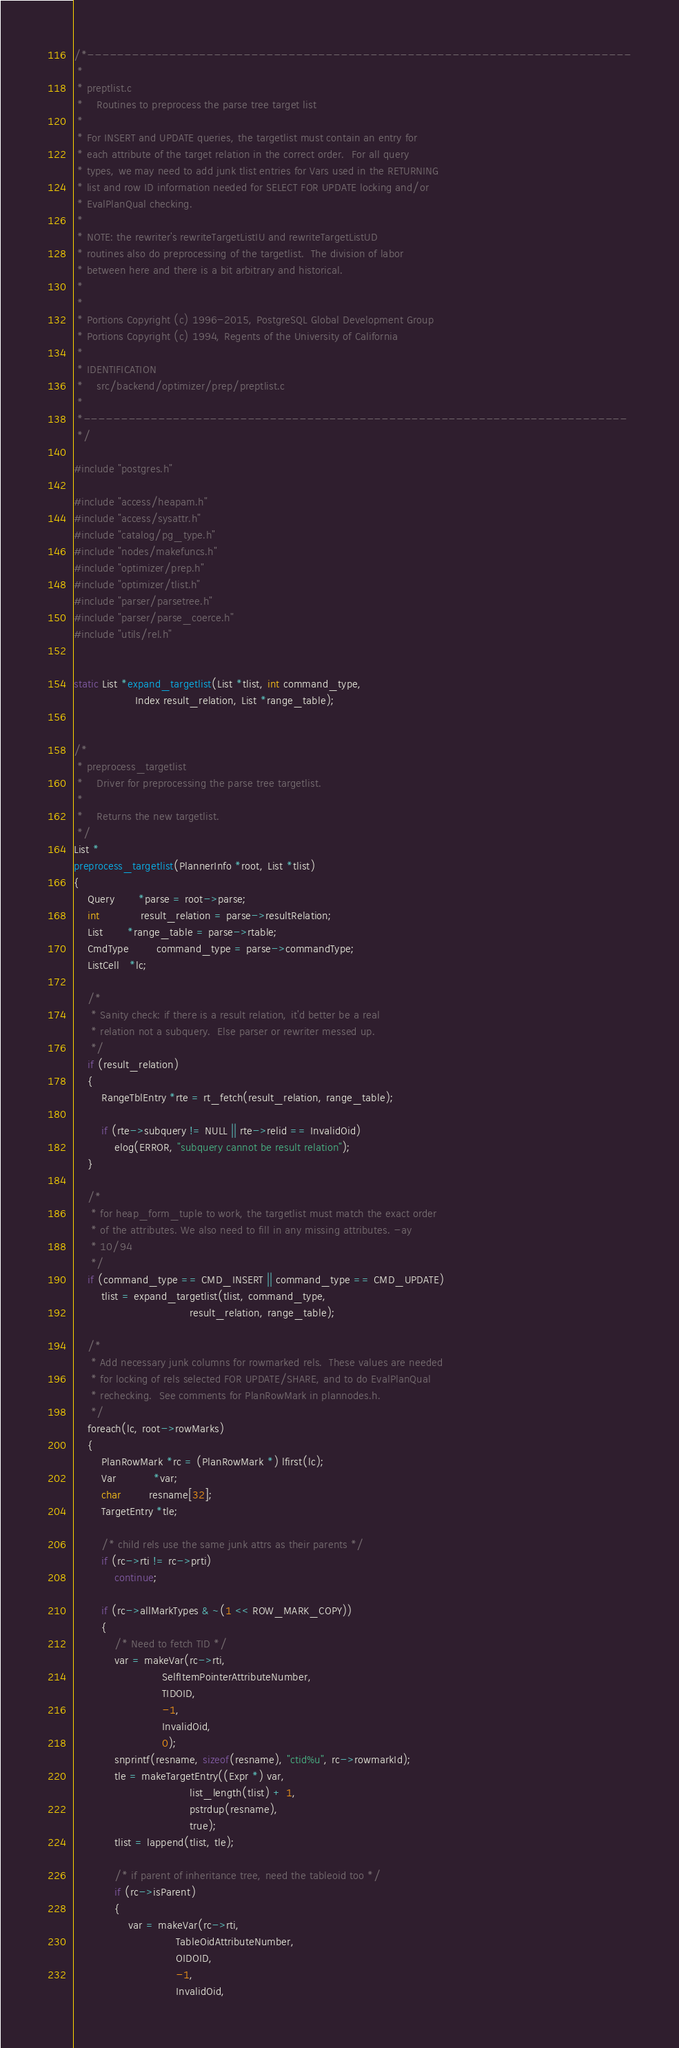Convert code to text. <code><loc_0><loc_0><loc_500><loc_500><_C_>/*-------------------------------------------------------------------------
 *
 * preptlist.c
 *	  Routines to preprocess the parse tree target list
 *
 * For INSERT and UPDATE queries, the targetlist must contain an entry for
 * each attribute of the target relation in the correct order.  For all query
 * types, we may need to add junk tlist entries for Vars used in the RETURNING
 * list and row ID information needed for SELECT FOR UPDATE locking and/or
 * EvalPlanQual checking.
 *
 * NOTE: the rewriter's rewriteTargetListIU and rewriteTargetListUD
 * routines also do preprocessing of the targetlist.  The division of labor
 * between here and there is a bit arbitrary and historical.
 *
 *
 * Portions Copyright (c) 1996-2015, PostgreSQL Global Development Group
 * Portions Copyright (c) 1994, Regents of the University of California
 *
 * IDENTIFICATION
 *	  src/backend/optimizer/prep/preptlist.c
 *
 *-------------------------------------------------------------------------
 */

#include "postgres.h"

#include "access/heapam.h"
#include "access/sysattr.h"
#include "catalog/pg_type.h"
#include "nodes/makefuncs.h"
#include "optimizer/prep.h"
#include "optimizer/tlist.h"
#include "parser/parsetree.h"
#include "parser/parse_coerce.h"
#include "utils/rel.h"


static List *expand_targetlist(List *tlist, int command_type,
				  Index result_relation, List *range_table);


/*
 * preprocess_targetlist
 *	  Driver for preprocessing the parse tree targetlist.
 *
 *	  Returns the new targetlist.
 */
List *
preprocess_targetlist(PlannerInfo *root, List *tlist)
{
	Query	   *parse = root->parse;
	int			result_relation = parse->resultRelation;
	List	   *range_table = parse->rtable;
	CmdType		command_type = parse->commandType;
	ListCell   *lc;

	/*
	 * Sanity check: if there is a result relation, it'd better be a real
	 * relation not a subquery.  Else parser or rewriter messed up.
	 */
	if (result_relation)
	{
		RangeTblEntry *rte = rt_fetch(result_relation, range_table);

		if (rte->subquery != NULL || rte->relid == InvalidOid)
			elog(ERROR, "subquery cannot be result relation");
	}

	/*
	 * for heap_form_tuple to work, the targetlist must match the exact order
	 * of the attributes. We also need to fill in any missing attributes. -ay
	 * 10/94
	 */
	if (command_type == CMD_INSERT || command_type == CMD_UPDATE)
		tlist = expand_targetlist(tlist, command_type,
								  result_relation, range_table);

	/*
	 * Add necessary junk columns for rowmarked rels.  These values are needed
	 * for locking of rels selected FOR UPDATE/SHARE, and to do EvalPlanQual
	 * rechecking.  See comments for PlanRowMark in plannodes.h.
	 */
	foreach(lc, root->rowMarks)
	{
		PlanRowMark *rc = (PlanRowMark *) lfirst(lc);
		Var		   *var;
		char		resname[32];
		TargetEntry *tle;

		/* child rels use the same junk attrs as their parents */
		if (rc->rti != rc->prti)
			continue;

		if (rc->allMarkTypes & ~(1 << ROW_MARK_COPY))
		{
			/* Need to fetch TID */
			var = makeVar(rc->rti,
						  SelfItemPointerAttributeNumber,
						  TIDOID,
						  -1,
						  InvalidOid,
						  0);
			snprintf(resname, sizeof(resname), "ctid%u", rc->rowmarkId);
			tle = makeTargetEntry((Expr *) var,
								  list_length(tlist) + 1,
								  pstrdup(resname),
								  true);
			tlist = lappend(tlist, tle);

			/* if parent of inheritance tree, need the tableoid too */
			if (rc->isParent)
			{
				var = makeVar(rc->rti,
							  TableOidAttributeNumber,
							  OIDOID,
							  -1,
							  InvalidOid,</code> 